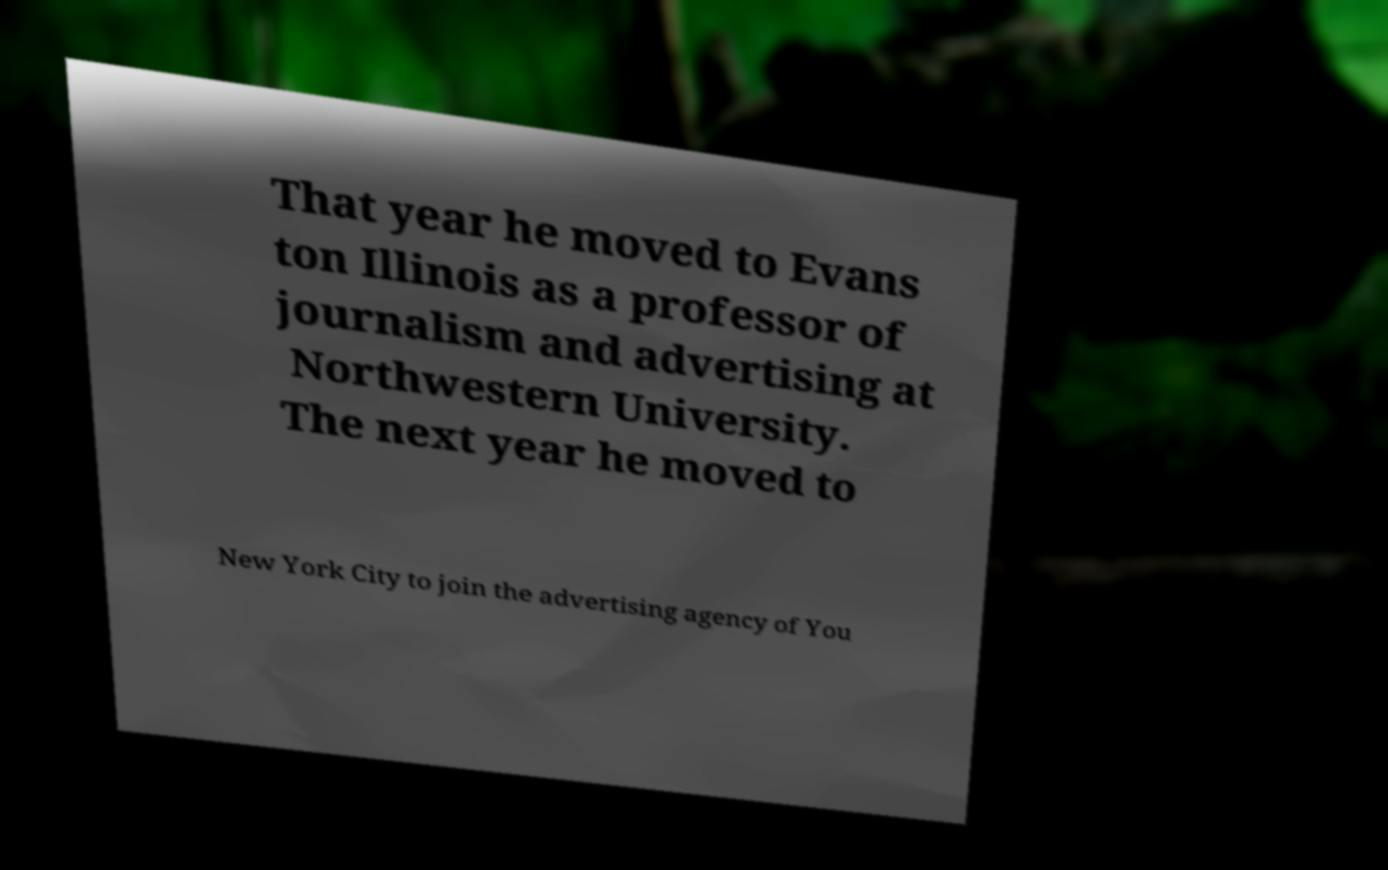Can you read and provide the text displayed in the image?This photo seems to have some interesting text. Can you extract and type it out for me? That year he moved to Evans ton Illinois as a professor of journalism and advertising at Northwestern University. The next year he moved to New York City to join the advertising agency of You 